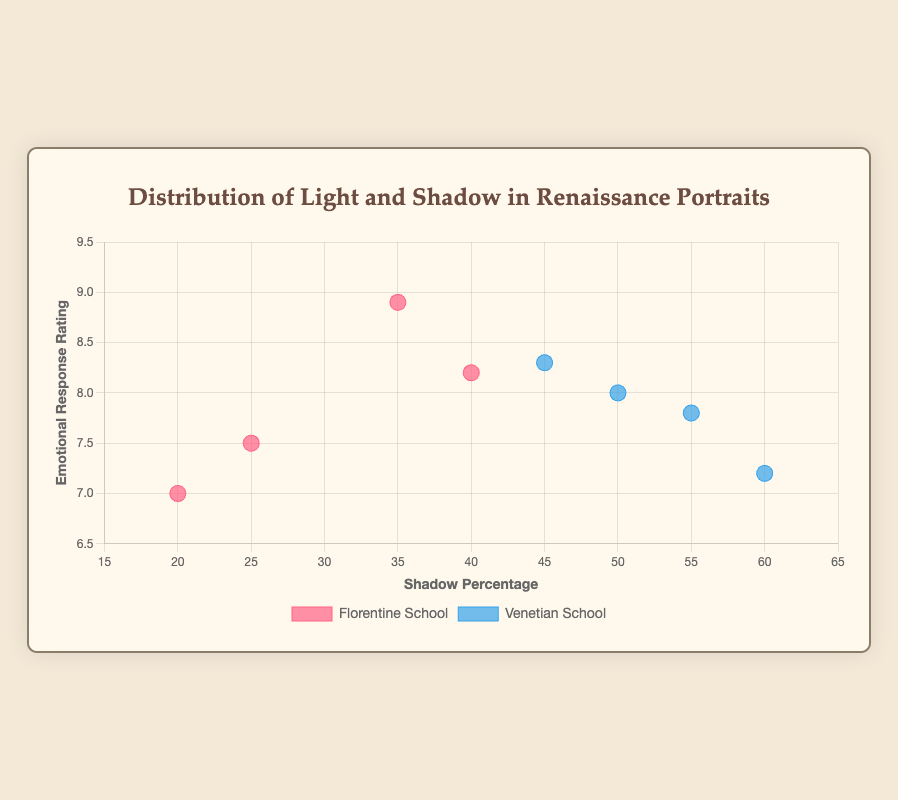What's the title of the scatter plot? The title can be found at the top of the plot. It says "Distribution of Light and Shadow in Renaissance Portraits".
Answer: Distribution of Light and Shadow in Renaissance Portraits What does the x-axis represent? The x-axis title is labeled "Shadow Percentage", indicating it represents the percentage of shadow in the portraits.
Answer: Shadow Percentage How many data points are there for the Florentine School? Each red dot represents a data point from the Florentine School. Counting all the red dots gives the total number.
Answer: 4 Which school has the highest emotional response rating, and what is it? The highest point on the y-axis needs to be identified and its corresponding school. The highest rating is 8.9 for the Florentine School.
Answer: Florentine (8.9) Which artist has the highest shadow percentage in their portrait from the Venetian School? For the Venetian School, find the point farthest to the right on the x-axis and check its tooltip label for the artist's name. The highest shadow percentage is 60% by Tintoretto.
Answer: Tintoretto Which Florentine portrait has the lowest shadow percentage? Identify the data point for the Florentine school with the lowest x-axis value (20%) and check its tooltip for details.
Answer: The Annunciation by Fra Angelico What is the average shadow percentage for the Venetian School? Sum the shadow percentages for all Venetian School portraits (55+50+60+45) and divide by the number of portraits (4). Total is 210, average is 210/4.
Answer: 52.5% Compare the average emotional response ratings between the two schools. Which is higher? Calculate the average for each school and compare. Florentine: (8.9+7.5+8.2+7.0)/4=7.9. Venetian: (7.8+8.0+7.2+8.3)/4=7.825.
Answer: Florentine Are the emotional response ratings generally higher or lower for portraits with higher shadow percentages? Observe the general trend where higher shadow percentages on the x-axis correspond with emotional response ratings on the y-axis.
Answer: Higher Which artist from the Florentine School has the highest emotional response rating? Identify the highest emotional response rating point for the Florentine school by checking the y-axis and confirming the artist's name using tooltips or referring to data.
Answer: Leonardo da Vinci (8.9) 